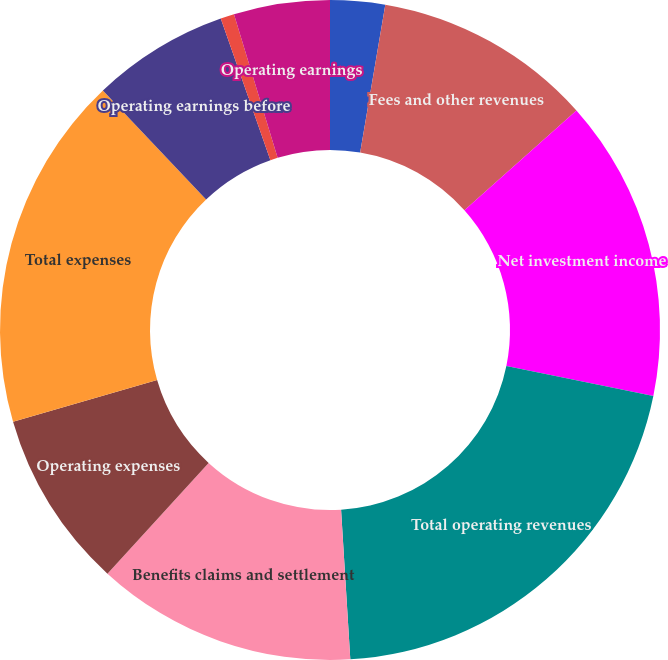<chart> <loc_0><loc_0><loc_500><loc_500><pie_chart><fcel>Premiums and other<fcel>Fees and other revenues<fcel>Net investment income<fcel>Total operating revenues<fcel>Benefits claims and settlement<fcel>Operating expenses<fcel>Total expenses<fcel>Operating earnings before<fcel>Income taxes<fcel>Operating earnings<nl><fcel>2.68%<fcel>10.74%<fcel>14.78%<fcel>20.82%<fcel>12.76%<fcel>8.73%<fcel>17.41%<fcel>6.71%<fcel>0.67%<fcel>4.7%<nl></chart> 